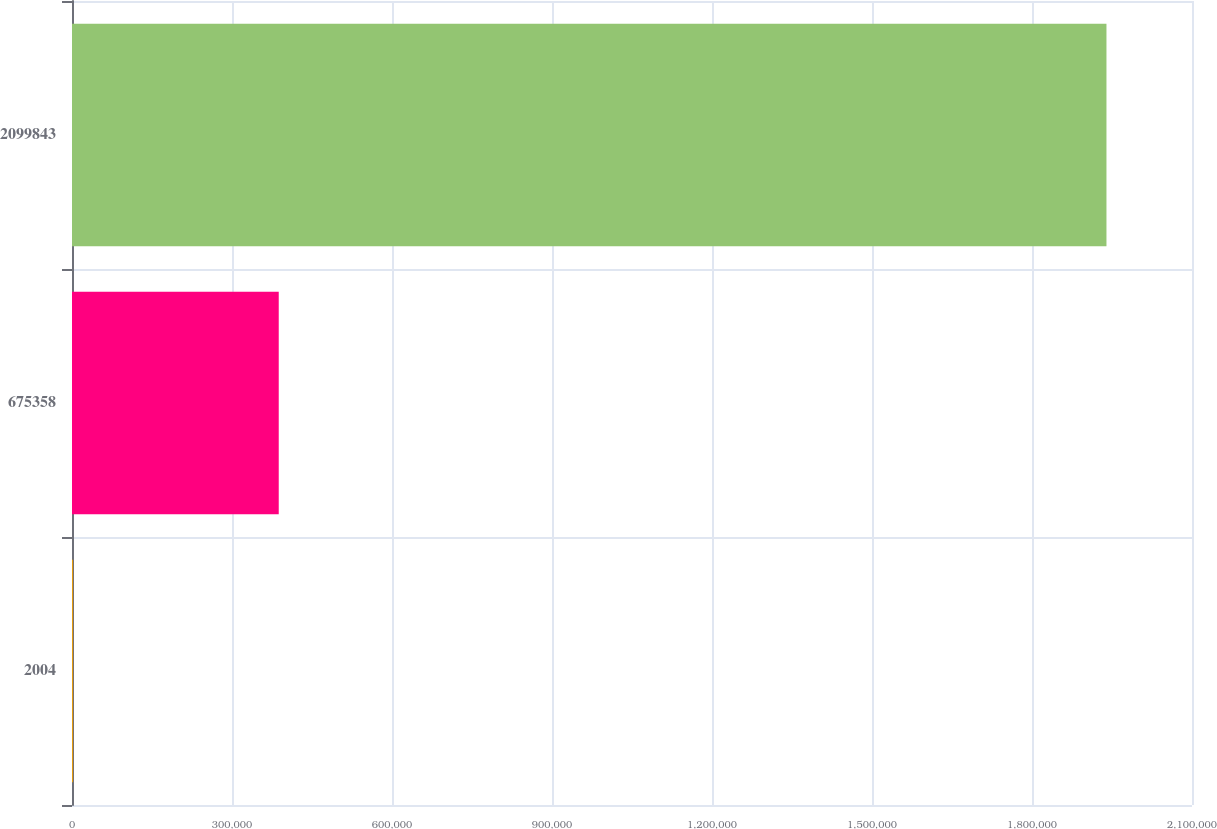Convert chart. <chart><loc_0><loc_0><loc_500><loc_500><bar_chart><fcel>2004<fcel>675358<fcel>2099843<nl><fcel>2002<fcel>387639<fcel>1.93962e+06<nl></chart> 